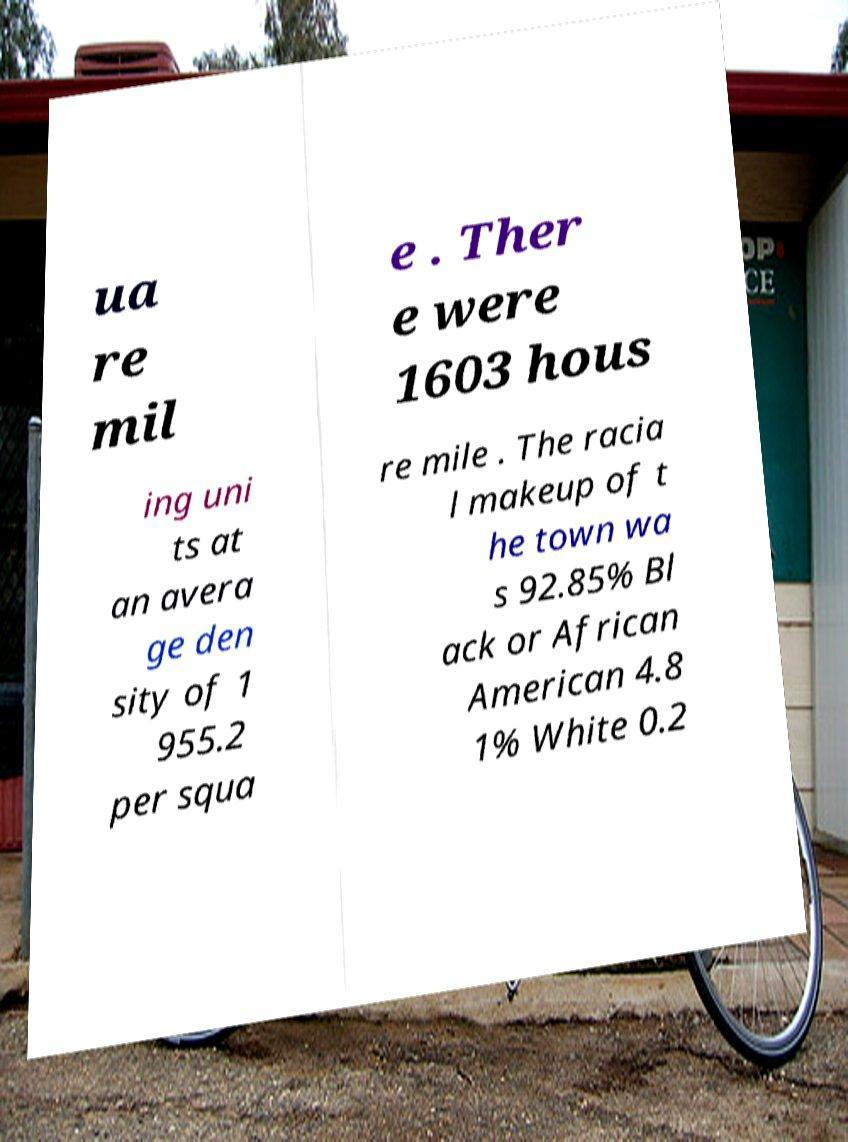Could you extract and type out the text from this image? ua re mil e . Ther e were 1603 hous ing uni ts at an avera ge den sity of 1 955.2 per squa re mile . The racia l makeup of t he town wa s 92.85% Bl ack or African American 4.8 1% White 0.2 